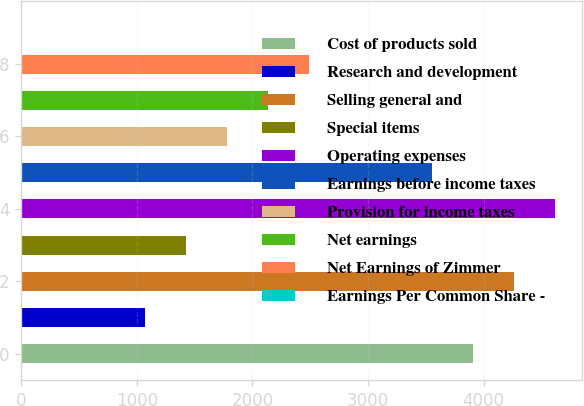<chart> <loc_0><loc_0><loc_500><loc_500><bar_chart><fcel>Cost of products sold<fcel>Research and development<fcel>Selling general and<fcel>Special items<fcel>Operating expenses<fcel>Earnings before income taxes<fcel>Provision for income taxes<fcel>Net earnings<fcel>Net Earnings of Zimmer<fcel>Earnings Per Common Share -<nl><fcel>3909.87<fcel>1069.63<fcel>4264.9<fcel>1424.66<fcel>4619.93<fcel>3554.84<fcel>1779.69<fcel>2134.72<fcel>2489.75<fcel>4.54<nl></chart> 